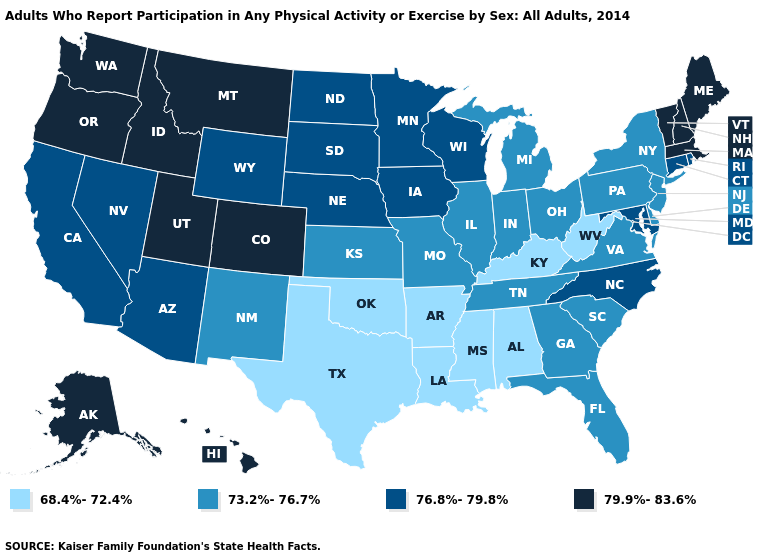Does the map have missing data?
Answer briefly. No. Name the states that have a value in the range 73.2%-76.7%?
Quick response, please. Delaware, Florida, Georgia, Illinois, Indiana, Kansas, Michigan, Missouri, New Jersey, New Mexico, New York, Ohio, Pennsylvania, South Carolina, Tennessee, Virginia. Does Maine have a higher value than Iowa?
Give a very brief answer. Yes. Among the states that border Indiana , which have the lowest value?
Keep it brief. Kentucky. Name the states that have a value in the range 79.9%-83.6%?
Short answer required. Alaska, Colorado, Hawaii, Idaho, Maine, Massachusetts, Montana, New Hampshire, Oregon, Utah, Vermont, Washington. What is the value of Oklahoma?
Quick response, please. 68.4%-72.4%. Name the states that have a value in the range 73.2%-76.7%?
Keep it brief. Delaware, Florida, Georgia, Illinois, Indiana, Kansas, Michigan, Missouri, New Jersey, New Mexico, New York, Ohio, Pennsylvania, South Carolina, Tennessee, Virginia. Which states hav the highest value in the Northeast?
Concise answer only. Maine, Massachusetts, New Hampshire, Vermont. Name the states that have a value in the range 76.8%-79.8%?
Short answer required. Arizona, California, Connecticut, Iowa, Maryland, Minnesota, Nebraska, Nevada, North Carolina, North Dakota, Rhode Island, South Dakota, Wisconsin, Wyoming. Does Texas have the lowest value in the South?
Give a very brief answer. Yes. Among the states that border Massachusetts , does New York have the highest value?
Write a very short answer. No. Does Rhode Island have the lowest value in the Northeast?
Keep it brief. No. Does New Jersey have the lowest value in the USA?
Answer briefly. No. Name the states that have a value in the range 73.2%-76.7%?
Concise answer only. Delaware, Florida, Georgia, Illinois, Indiana, Kansas, Michigan, Missouri, New Jersey, New Mexico, New York, Ohio, Pennsylvania, South Carolina, Tennessee, Virginia. Name the states that have a value in the range 79.9%-83.6%?
Short answer required. Alaska, Colorado, Hawaii, Idaho, Maine, Massachusetts, Montana, New Hampshire, Oregon, Utah, Vermont, Washington. 